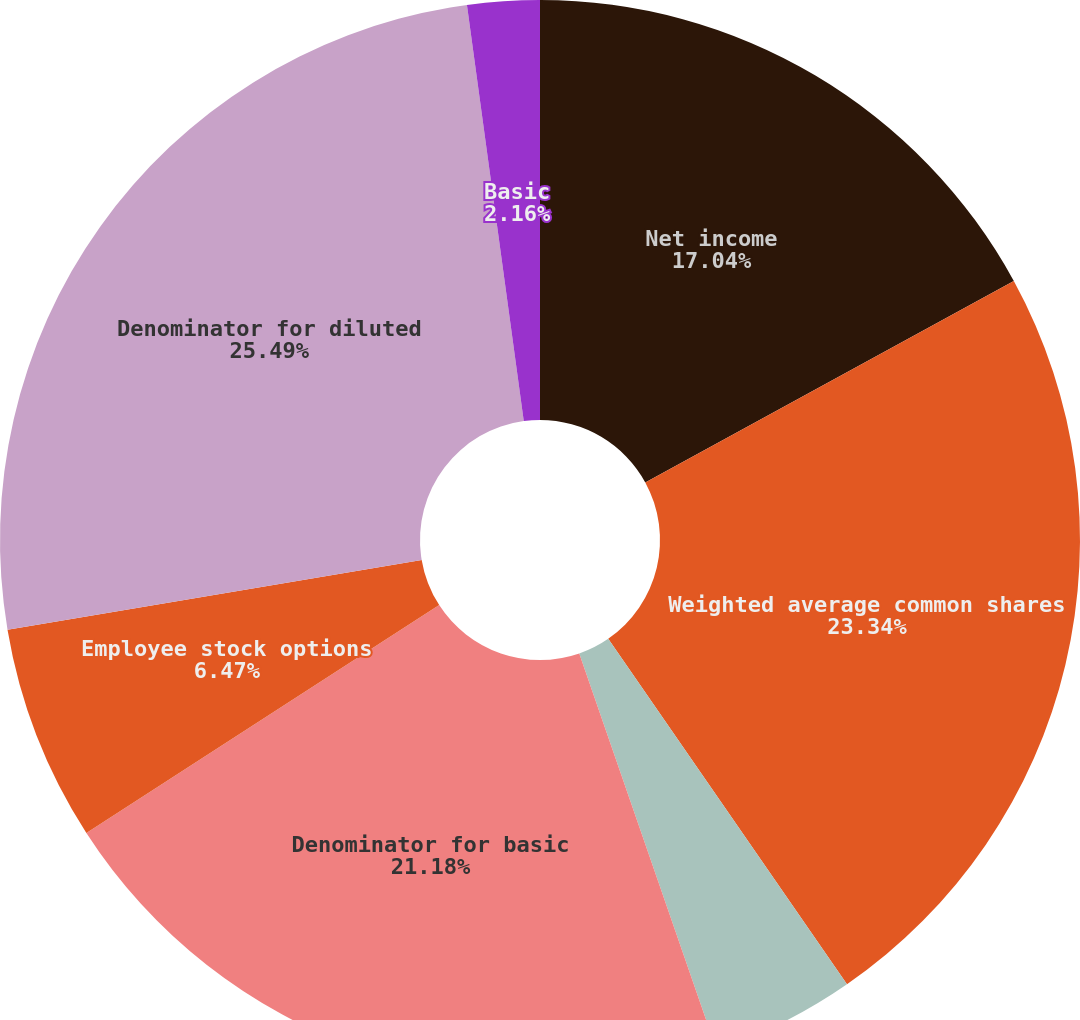<chart> <loc_0><loc_0><loc_500><loc_500><pie_chart><fcel>Net income<fcel>Weighted average common shares<fcel>Weighted average nonvested<fcel>Denominator for basic<fcel>Employee stock options<fcel>Denominator for diluted<fcel>Basic<fcel>Diluted<nl><fcel>17.04%<fcel>23.34%<fcel>4.32%<fcel>21.18%<fcel>6.47%<fcel>25.5%<fcel>2.16%<fcel>0.0%<nl></chart> 